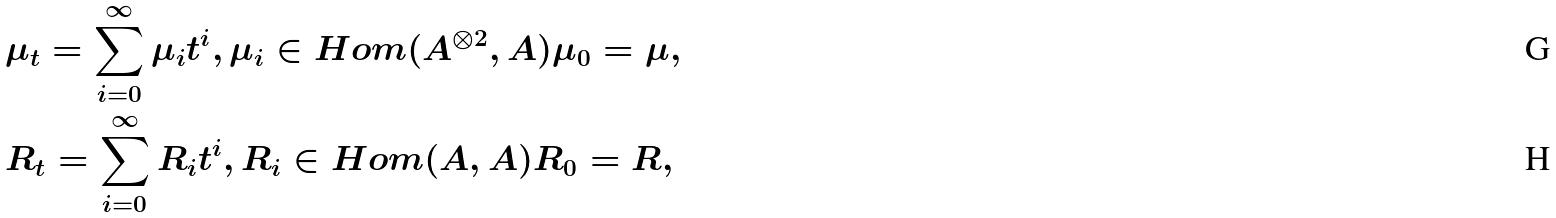Convert formula to latex. <formula><loc_0><loc_0><loc_500><loc_500>& \mu _ { t } = \sum _ { i = 0 } ^ { \infty } \mu _ { i } t ^ { i } , \mu _ { i } \in H o m ( A ^ { \otimes 2 } , A ) \mu _ { 0 } = \mu , \\ & R _ { t } = \sum _ { i = 0 } ^ { \infty } R _ { i } t ^ { i } , R _ { i } \in H o m ( A , A ) R _ { 0 } = R ,</formula> 